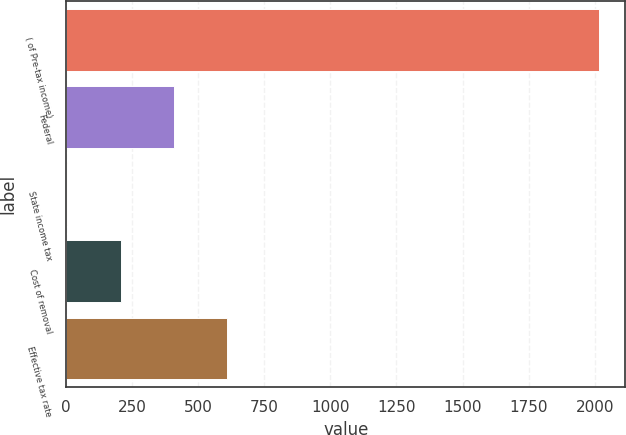Convert chart to OTSL. <chart><loc_0><loc_0><loc_500><loc_500><bar_chart><fcel>( of Pre-tax income)<fcel>Federal<fcel>State income tax<fcel>Cost of removal<fcel>Effective tax rate<nl><fcel>2015<fcel>407<fcel>5<fcel>206<fcel>608<nl></chart> 